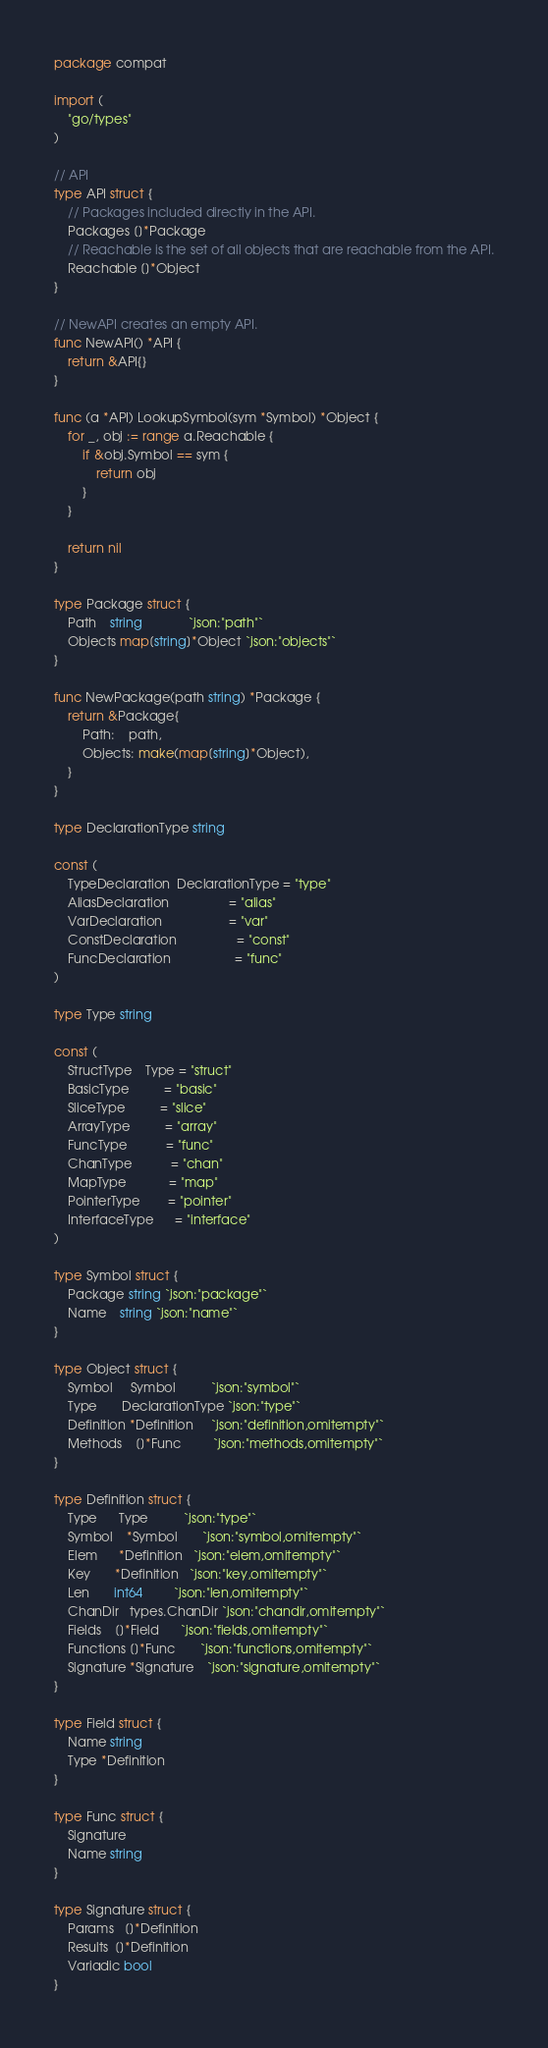<code> <loc_0><loc_0><loc_500><loc_500><_Go_>package compat

import (
	"go/types"
)

// API
type API struct {
	// Packages included directly in the API.
	Packages []*Package
	// Reachable is the set of all objects that are reachable from the API.
	Reachable []*Object
}

// NewAPI creates an empty API.
func NewAPI() *API {
	return &API{}
}

func (a *API) LookupSymbol(sym *Symbol) *Object {
	for _, obj := range a.Reachable {
		if &obj.Symbol == sym {
			return obj
		}
	}

	return nil
}

type Package struct {
	Path    string             `json:"path"`
	Objects map[string]*Object `json:"objects"`
}

func NewPackage(path string) *Package {
	return &Package{
		Path:    path,
		Objects: make(map[string]*Object),
	}
}

type DeclarationType string

const (
	TypeDeclaration  DeclarationType = "type"
	AliasDeclaration                 = "alias"
	VarDeclaration                   = "var"
	ConstDeclaration                 = "const"
	FuncDeclaration                  = "func"
)

type Type string

const (
	StructType    Type = "struct"
	BasicType          = "basic"
	SliceType          = "slice"
	ArrayType          = "array"
	FuncType           = "func"
	ChanType           = "chan"
	MapType            = "map"
	PointerType        = "pointer"
	InterfaceType      = "interface"
)

type Symbol struct {
	Package string `json:"package"`
	Name    string `json:"name"`
}

type Object struct {
	Symbol     Symbol          `json:"symbol"`
	Type       DeclarationType `json:"type"`
	Definition *Definition     `json:"definition,omitempty"`
	Methods    []*Func         `json:"methods,omitempty"`
}

type Definition struct {
	Type      Type          `json:"type"`
	Symbol    *Symbol       `json:"symbol,omitempty"`
	Elem      *Definition   `json:"elem,omitempty"`
	Key       *Definition   `json:"key,omitempty"`
	Len       int64         `json:"len,omitempty"`
	ChanDir   types.ChanDir `json:"chandir,omitempty"`
	Fields    []*Field      `json:"fields,omitempty"`
	Functions []*Func       `json:"functions,omitempty"`
	Signature *Signature    `json:"signature,omitempty"`
}

type Field struct {
	Name string
	Type *Definition
}

type Func struct {
	Signature
	Name string
}

type Signature struct {
	Params   []*Definition
	Results  []*Definition
	Variadic bool
}
</code> 